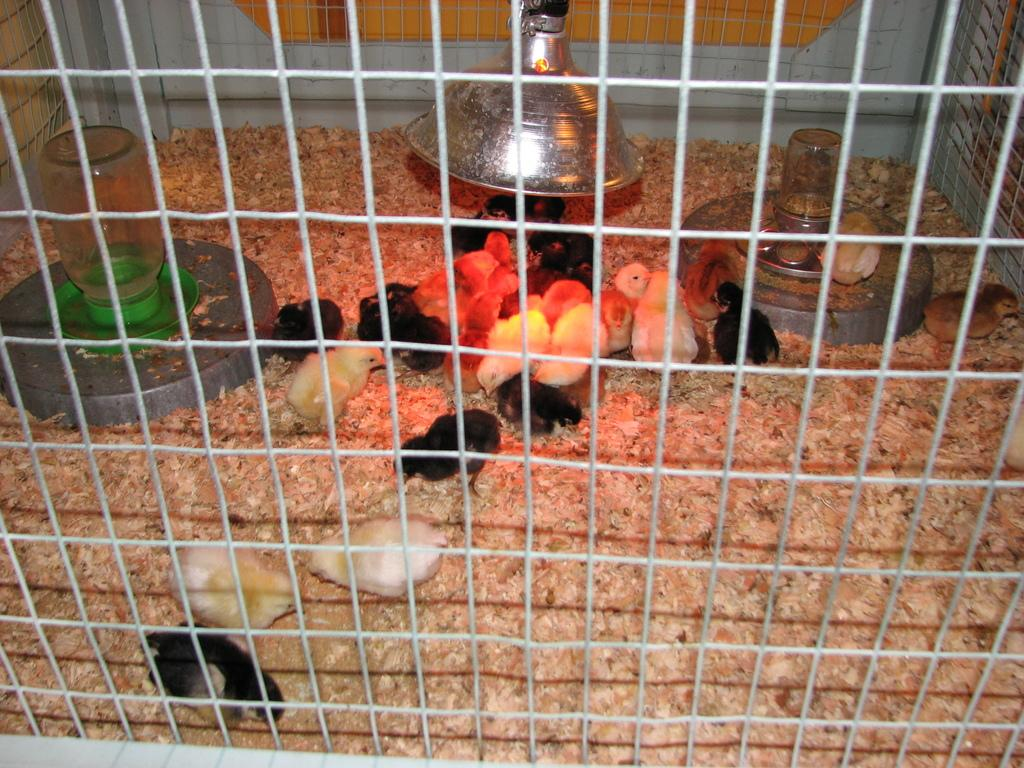What type of animals are in the image? There are chicks in the image. Where are the chicks located? The chicks are in a cage. What else can be seen in the cage besides the chicks? There are objects in the cage. How many snakes are present in the image? There are no snakes present in the image; it features chicks in a cage. 